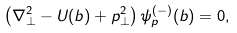Convert formula to latex. <formula><loc_0><loc_0><loc_500><loc_500>\left ( \nabla _ { \perp } ^ { 2 } - U ( b ) + p _ { \perp } ^ { 2 } \right ) \psi _ { p } ^ { ( - ) } ( b ) = 0 ,</formula> 